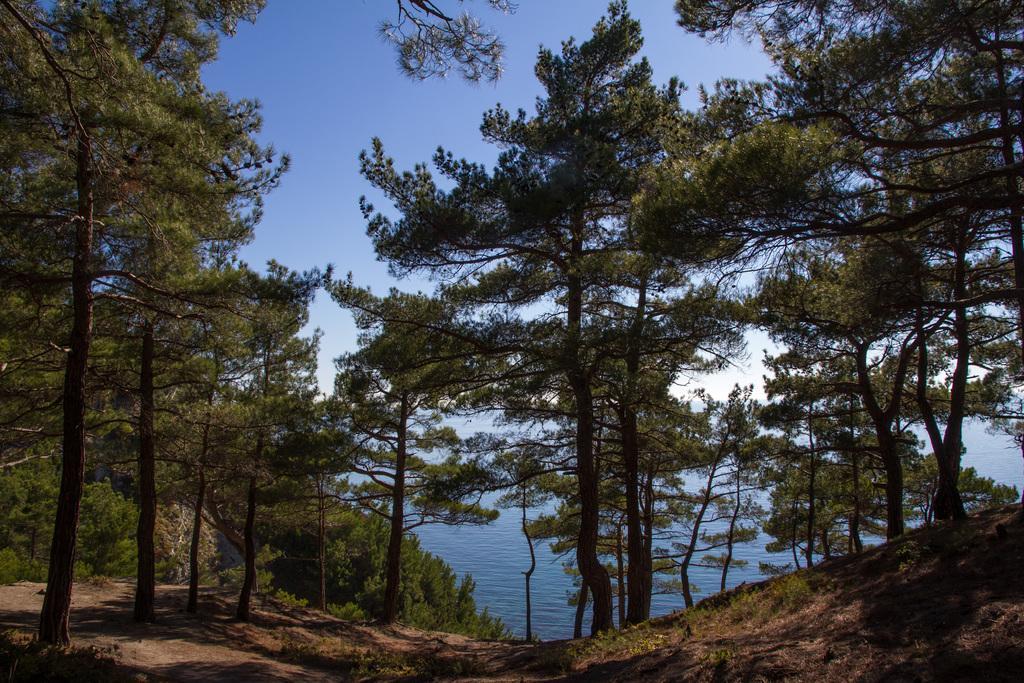How would you summarize this image in a sentence or two? In this image we can see trees. In the background there is water and sky. 